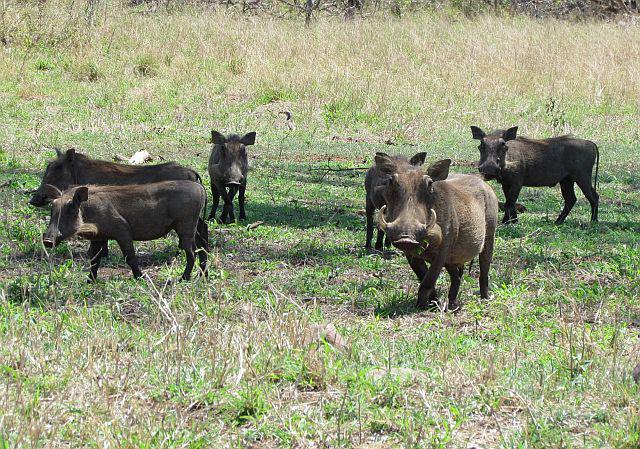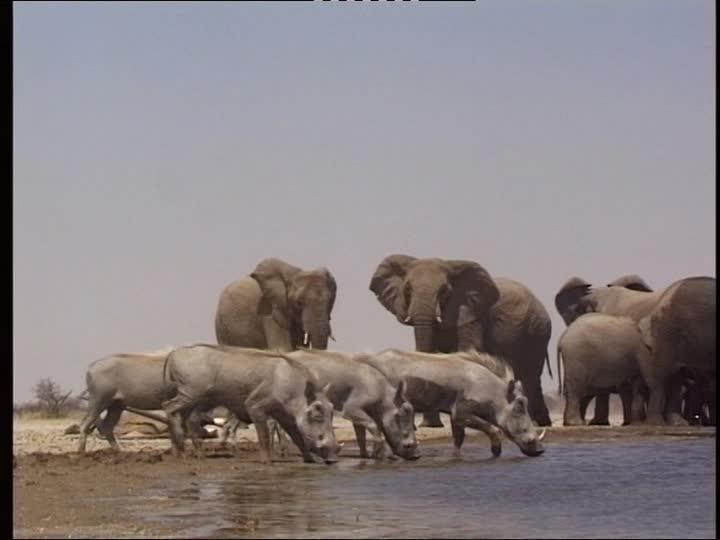The first image is the image on the left, the second image is the image on the right. Evaluate the accuracy of this statement regarding the images: "There are at least 5 black animals in th eimage on the left.". Is it true? Answer yes or no. Yes. The first image is the image on the left, the second image is the image on the right. Evaluate the accuracy of this statement regarding the images: "In one of the images there is a group of warthogs standing near water.". Is it true? Answer yes or no. Yes. 